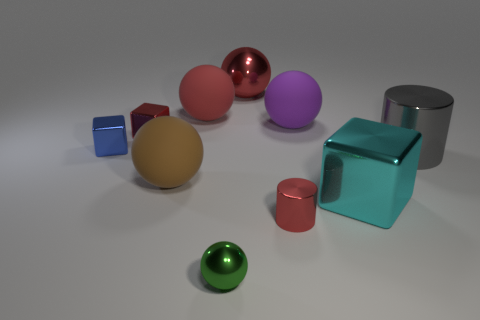What can you infer about the lighting in the scene based on the shadows of the objects? The shadows in the image are soft and diffused, suggesting a distant or large light source, possibly an overhead softbox or a cloudy day if this were outdoors, which provides uniform illumination while minimizing harsh shadows. 